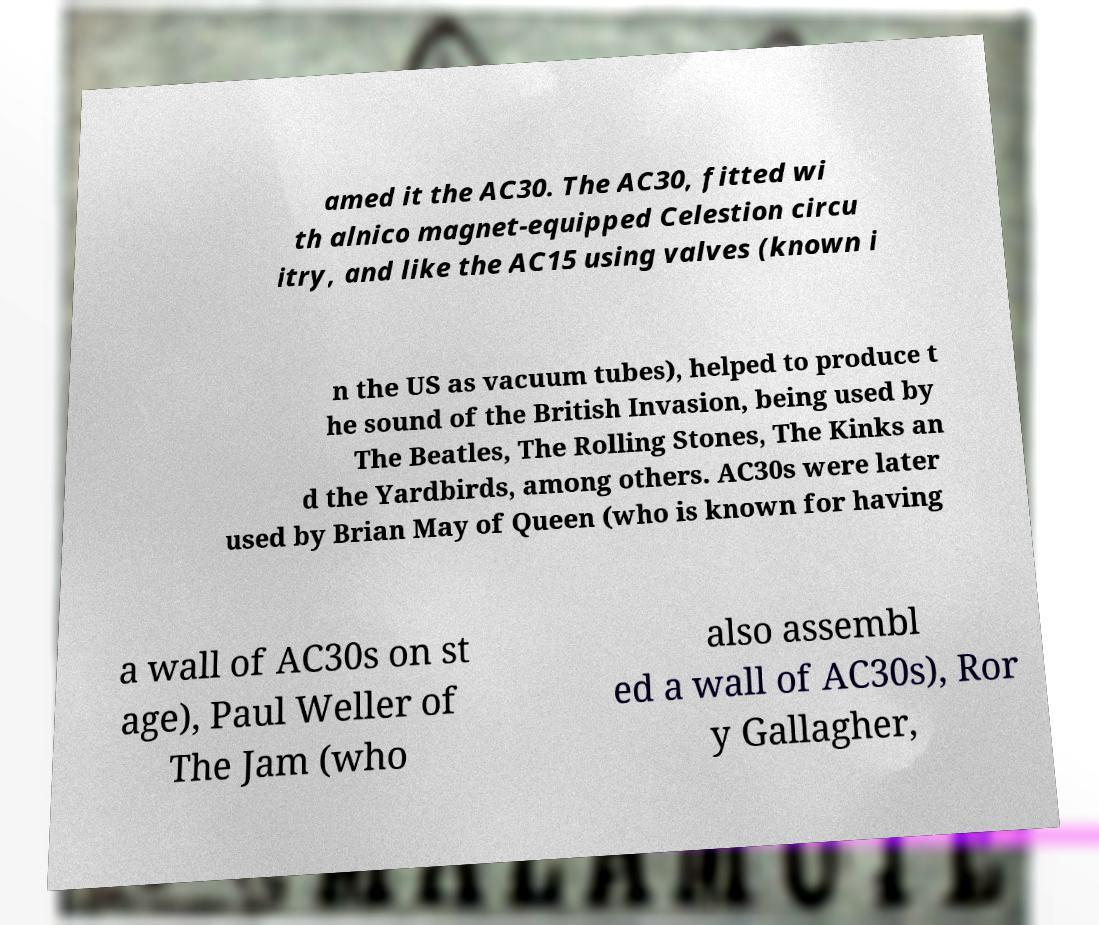I need the written content from this picture converted into text. Can you do that? amed it the AC30. The AC30, fitted wi th alnico magnet-equipped Celestion circu itry, and like the AC15 using valves (known i n the US as vacuum tubes), helped to produce t he sound of the British Invasion, being used by The Beatles, The Rolling Stones, The Kinks an d the Yardbirds, among others. AC30s were later used by Brian May of Queen (who is known for having a wall of AC30s on st age), Paul Weller of The Jam (who also assembl ed a wall of AC30s), Ror y Gallagher, 